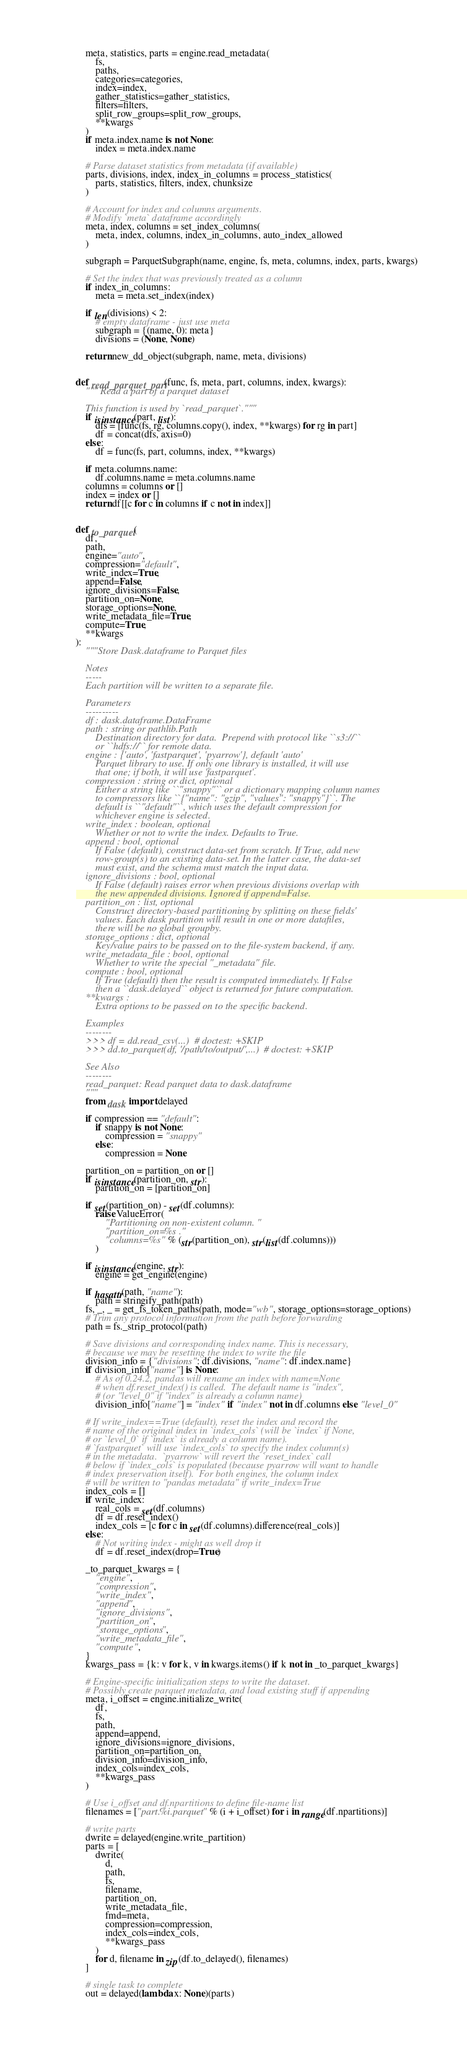Convert code to text. <code><loc_0><loc_0><loc_500><loc_500><_Python_>
    meta, statistics, parts = engine.read_metadata(
        fs,
        paths,
        categories=categories,
        index=index,
        gather_statistics=gather_statistics,
        filters=filters,
        split_row_groups=split_row_groups,
        **kwargs
    )
    if meta.index.name is not None:
        index = meta.index.name

    # Parse dataset statistics from metadata (if available)
    parts, divisions, index, index_in_columns = process_statistics(
        parts, statistics, filters, index, chunksize
    )

    # Account for index and columns arguments.
    # Modify `meta` dataframe accordingly
    meta, index, columns = set_index_columns(
        meta, index, columns, index_in_columns, auto_index_allowed
    )

    subgraph = ParquetSubgraph(name, engine, fs, meta, columns, index, parts, kwargs)

    # Set the index that was previously treated as a column
    if index_in_columns:
        meta = meta.set_index(index)

    if len(divisions) < 2:
        # empty dataframe - just use meta
        subgraph = {(name, 0): meta}
        divisions = (None, None)

    return new_dd_object(subgraph, name, meta, divisions)


def read_parquet_part(func, fs, meta, part, columns, index, kwargs):
    """ Read a part of a parquet dataset

    This function is used by `read_parquet`."""
    if isinstance(part, list):
        dfs = [func(fs, rg, columns.copy(), index, **kwargs) for rg in part]
        df = concat(dfs, axis=0)
    else:
        df = func(fs, part, columns, index, **kwargs)

    if meta.columns.name:
        df.columns.name = meta.columns.name
    columns = columns or []
    index = index or []
    return df[[c for c in columns if c not in index]]


def to_parquet(
    df,
    path,
    engine="auto",
    compression="default",
    write_index=True,
    append=False,
    ignore_divisions=False,
    partition_on=None,
    storage_options=None,
    write_metadata_file=True,
    compute=True,
    **kwargs
):
    """Store Dask.dataframe to Parquet files

    Notes
    -----
    Each partition will be written to a separate file.

    Parameters
    ----------
    df : dask.dataframe.DataFrame
    path : string or pathlib.Path
        Destination directory for data.  Prepend with protocol like ``s3://``
        or ``hdfs://`` for remote data.
    engine : {'auto', 'fastparquet', 'pyarrow'}, default 'auto'
        Parquet library to use. If only one library is installed, it will use
        that one; if both, it will use 'fastparquet'.
    compression : string or dict, optional
        Either a string like ``"snappy"`` or a dictionary mapping column names
        to compressors like ``{"name": "gzip", "values": "snappy"}``. The
        default is ``"default"``, which uses the default compression for
        whichever engine is selected.
    write_index : boolean, optional
        Whether or not to write the index. Defaults to True.
    append : bool, optional
        If False (default), construct data-set from scratch. If True, add new
        row-group(s) to an existing data-set. In the latter case, the data-set
        must exist, and the schema must match the input data.
    ignore_divisions : bool, optional
        If False (default) raises error when previous divisions overlap with
        the new appended divisions. Ignored if append=False.
    partition_on : list, optional
        Construct directory-based partitioning by splitting on these fields'
        values. Each dask partition will result in one or more datafiles,
        there will be no global groupby.
    storage_options : dict, optional
        Key/value pairs to be passed on to the file-system backend, if any.
    write_metadata_file : bool, optional
        Whether to write the special "_metadata" file.
    compute : bool, optional
        If True (default) then the result is computed immediately. If False
        then a ``dask.delayed`` object is returned for future computation.
    **kwargs :
        Extra options to be passed on to the specific backend.

    Examples
    --------
    >>> df = dd.read_csv(...)  # doctest: +SKIP
    >>> dd.to_parquet(df, '/path/to/output/',...)  # doctest: +SKIP

    See Also
    --------
    read_parquet: Read parquet data to dask.dataframe
    """
    from dask import delayed

    if compression == "default":
        if snappy is not None:
            compression = "snappy"
        else:
            compression = None

    partition_on = partition_on or []
    if isinstance(partition_on, str):
        partition_on = [partition_on]

    if set(partition_on) - set(df.columns):
        raise ValueError(
            "Partitioning on non-existent column. "
            "partition_on=%s ."
            "columns=%s" % (str(partition_on), str(list(df.columns)))
        )

    if isinstance(engine, str):
        engine = get_engine(engine)

    if hasattr(path, "name"):
        path = stringify_path(path)
    fs, _, _ = get_fs_token_paths(path, mode="wb", storage_options=storage_options)
    # Trim any protocol information from the path before forwarding
    path = fs._strip_protocol(path)

    # Save divisions and corresponding index name. This is necessary,
    # because we may be resetting the index to write the file
    division_info = {"divisions": df.divisions, "name": df.index.name}
    if division_info["name"] is None:
        # As of 0.24.2, pandas will rename an index with name=None
        # when df.reset_index() is called.  The default name is "index",
        # (or "level_0" if "index" is already a column name)
        division_info["name"] = "index" if "index" not in df.columns else "level_0"

    # If write_index==True (default), reset the index and record the
    # name of the original index in `index_cols` (will be `index` if None,
    # or `level_0` if `index` is already a column name).
    # `fastparquet` will use `index_cols` to specify the index column(s)
    # in the metadata.  `pyarrow` will revert the `reset_index` call
    # below if `index_cols` is populated (because pyarrow will want to handle
    # index preservation itself).  For both engines, the column index
    # will be written to "pandas metadata" if write_index=True
    index_cols = []
    if write_index:
        real_cols = set(df.columns)
        df = df.reset_index()
        index_cols = [c for c in set(df.columns).difference(real_cols)]
    else:
        # Not writing index - might as well drop it
        df = df.reset_index(drop=True)

    _to_parquet_kwargs = {
        "engine",
        "compression",
        "write_index",
        "append",
        "ignore_divisions",
        "partition_on",
        "storage_options",
        "write_metadata_file",
        "compute",
    }
    kwargs_pass = {k: v for k, v in kwargs.items() if k not in _to_parquet_kwargs}

    # Engine-specific initialization steps to write the dataset.
    # Possibly create parquet metadata, and load existing stuff if appending
    meta, i_offset = engine.initialize_write(
        df,
        fs,
        path,
        append=append,
        ignore_divisions=ignore_divisions,
        partition_on=partition_on,
        division_info=division_info,
        index_cols=index_cols,
        **kwargs_pass
    )

    # Use i_offset and df.npartitions to define file-name list
    filenames = ["part.%i.parquet" % (i + i_offset) for i in range(df.npartitions)]

    # write parts
    dwrite = delayed(engine.write_partition)
    parts = [
        dwrite(
            d,
            path,
            fs,
            filename,
            partition_on,
            write_metadata_file,
            fmd=meta,
            compression=compression,
            index_cols=index_cols,
            **kwargs_pass
        )
        for d, filename in zip(df.to_delayed(), filenames)
    ]

    # single task to complete
    out = delayed(lambda x: None)(parts)</code> 